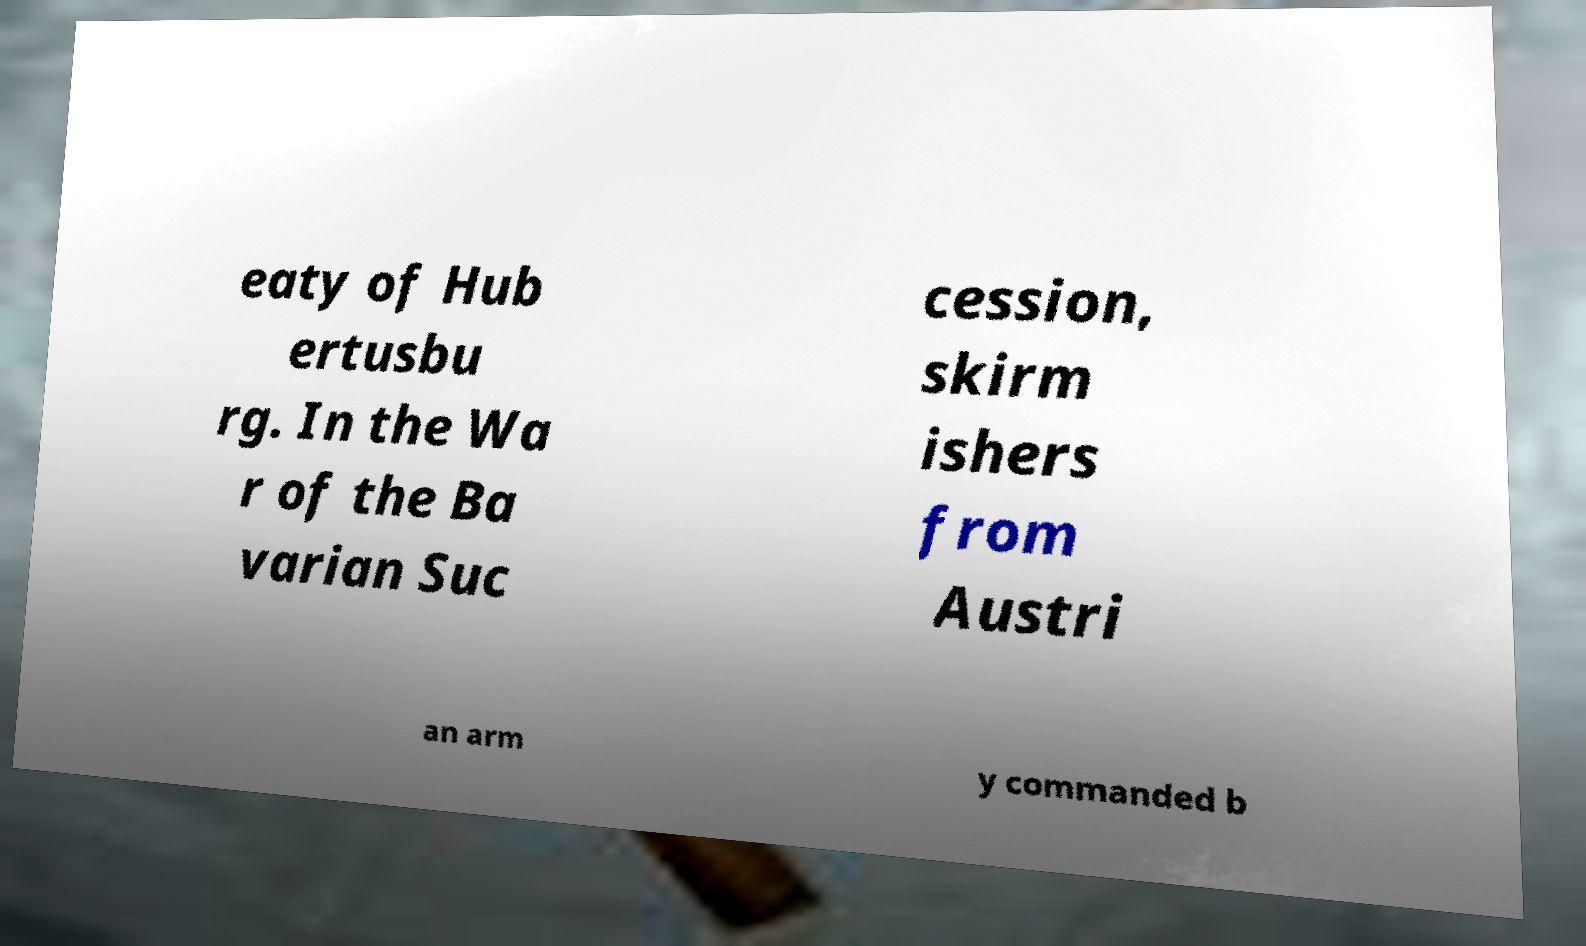I need the written content from this picture converted into text. Can you do that? eaty of Hub ertusbu rg. In the Wa r of the Ba varian Suc cession, skirm ishers from Austri an arm y commanded b 